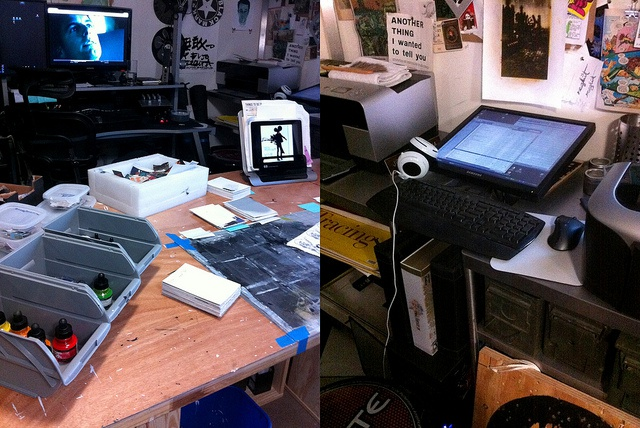Describe the objects in this image and their specific colors. I can see dining table in black, salmon, gray, white, and darkblue tones, tv in black, lightblue, and gray tones, keyboard in black, gray, and darkgray tones, tv in black, white, navy, and blue tones, and chair in black, lavender, gray, and darkgray tones in this image. 